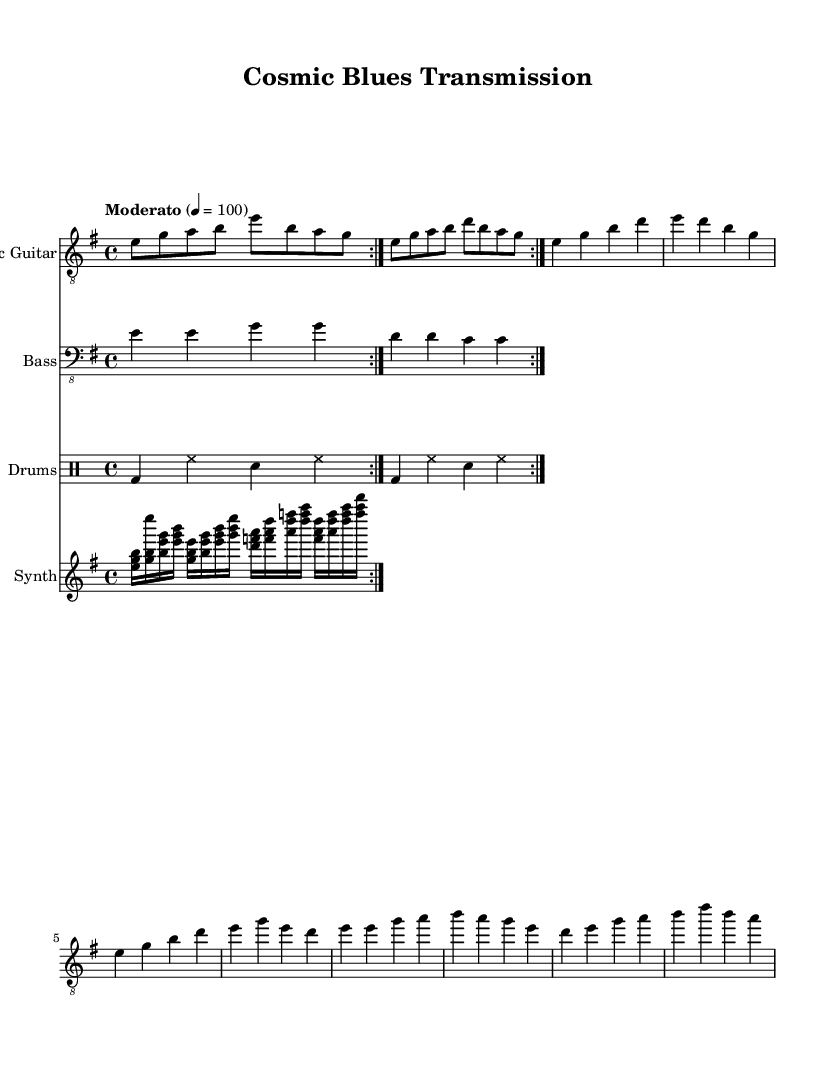What is the key signature of this music? The key signature is E minor, which has one sharp (F#). In the sheet music, the key is indicated before the time signature at the beginning.
Answer: E minor What is the time signature of this music? The time signature is 4/4, which means there are four beats per measure. This is shown in the notation near the key signature at the start of the score.
Answer: 4/4 What is the tempo marking? The tempo marking is "Moderato," which indicates a moderate speed for the piece. This is specified at the beginning of the score right after the time signature.
Answer: Moderato How many times is the guitar riff repeated? The guitar riff is repeated two times, as indicated by the "repeat volta 2" markings in the electric guitar part. This notation specifies that the section should be played twice.
Answer: 2 What is the instrumental composition of this piece? The piece consists of four instruments: Electric Guitar, Bass, Drums, and Synth. Each of these is represented in separate staves throughout the score.
Answer: Electric Guitar, Bass, Drums, Synth What kind of musical devices are used in the synth part? The synth part features pulsating arpeggios, which are indicated by the rapid succession of notes played in a specific pattern. This is evident in the notated chords that appear in succession.
Answer: Pulsating arpeggios How does the bass line contribute to the overall feel of the blues genre? The bass line provides a foundational rhythm and tone that supports the harmonic structure typical of blues music. It uses simple repeated patterns which create a groovy backdrop for the guitar and drums.
Answer: Groovy backdrop 